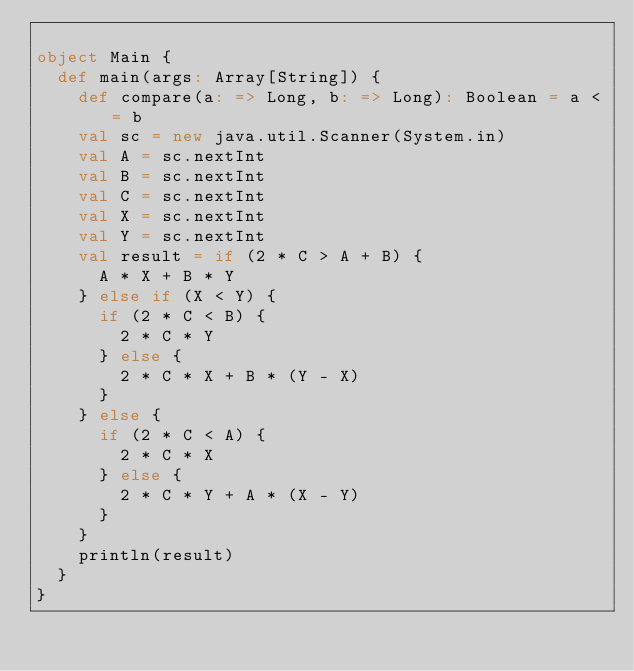<code> <loc_0><loc_0><loc_500><loc_500><_Scala_>
object Main {
  def main(args: Array[String]) {
    def compare(a: => Long, b: => Long): Boolean = a <= b
    val sc = new java.util.Scanner(System.in)
    val A = sc.nextInt
    val B = sc.nextInt
    val C = sc.nextInt
    val X = sc.nextInt
    val Y = sc.nextInt
    val result = if (2 * C > A + B) {
      A * X + B * Y
    } else if (X < Y) {
      if (2 * C < B) {
        2 * C * Y
      } else {
        2 * C * X + B * (Y - X)
      }
    } else {
      if (2 * C < A) {
        2 * C * X
      } else {
        2 * C * Y + A * (X - Y)
      }
    }
    println(result)
  }
}</code> 